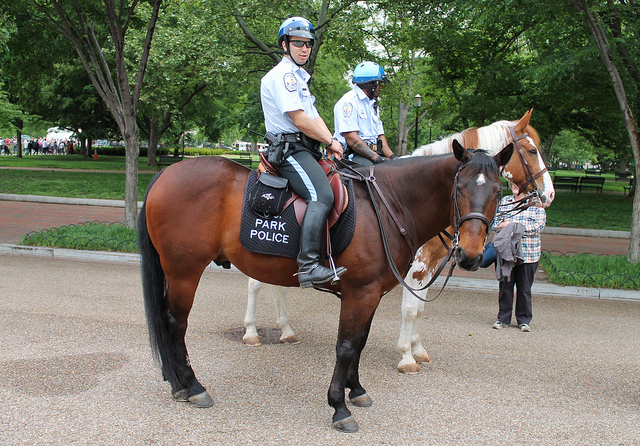Extract all visible text content from this image. PARK POLICE 